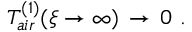<formula> <loc_0><loc_0><loc_500><loc_500>T _ { a i r } ^ { ( 1 ) } ( \xi \to \infty ) \, \to \, 0 \ . \</formula> 